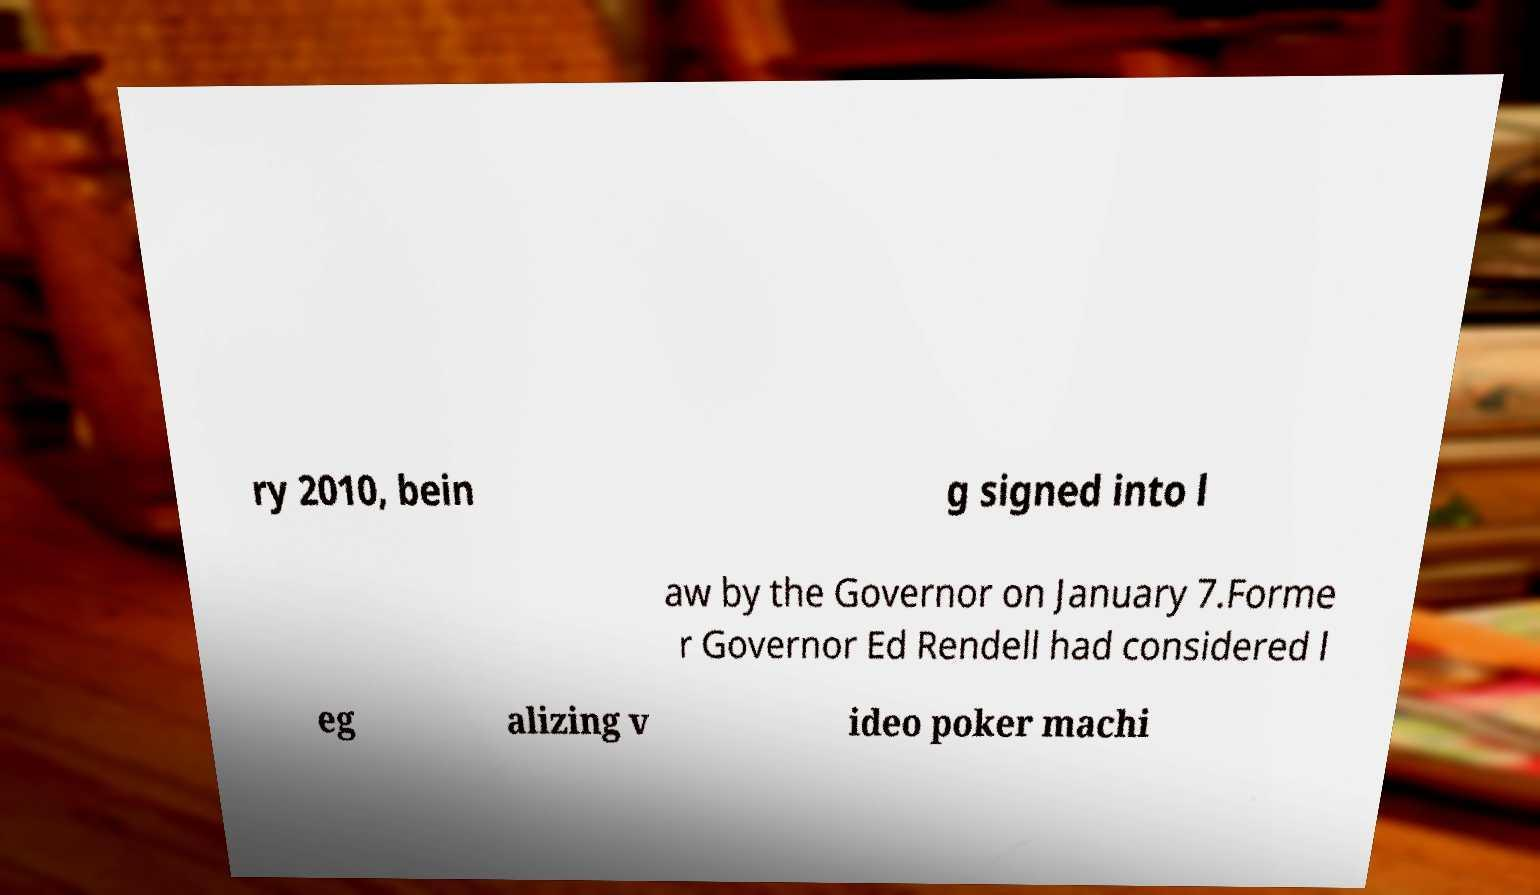Could you assist in decoding the text presented in this image and type it out clearly? ry 2010, bein g signed into l aw by the Governor on January 7.Forme r Governor Ed Rendell had considered l eg alizing v ideo poker machi 